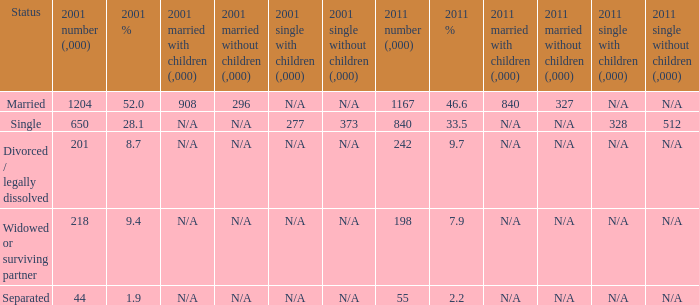What is the 2011 number (,000) when the status is separated? 55.0. 